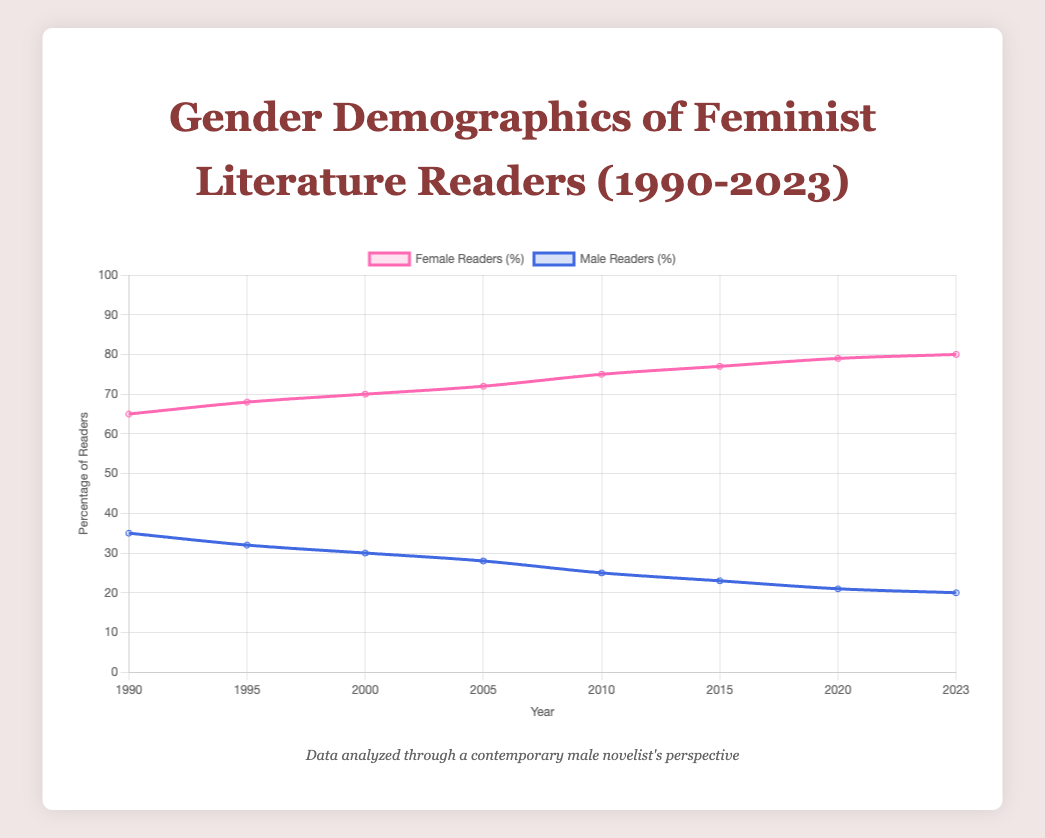What is the general trend in the percentage of female readers from 1990 to 2023? To answer this, examine the data points specifically for female readers from 1990 to 2023. Visual analysis of the line chart indicates a steady increase in the percentage of female readers over this period.
Answer: An increasing trend How did the percentage of male readers change between 1990 and 2000? Look at the male readers' percentages in 1990 and 2000. In 1990, it was 35%, and by 2000, it had decreased to 30%. The percentage of male readers decreased by 5%.
Answer: Decreased by 5% Which year saw the highest percentage of female readers, and what was it? By examining the data points or the line chart's peak for female readers, 2023 shows the highest value, with female readers at 80%.
Answer: 2023 with 80% Compare the percentage of male and female readers in 2010. How much higher is the percentage of female readers compared to male readers? In 2010, female readers were at 75%, and male readers were at 25%. The percentage of female readers is 50% higher than male readers.
Answer: 50% higher Calculate the average annual percentage difference in female readers from 1990 to 2023. Add the differences in percentage for each 5-year interval first: (68-65) + (70-68) + (72-70) + (75-72) + (77-75) + (79-77) + (80-79) = 3 + 2 + 2 + 3 + 2 + 2 + 1 = 15. Then divide by 7 intervals: 15/7 ≈ 2.14%
Answer: 2.14% In which period did the percentage of male readers decrease the most, and what was the amount? Examine the decreases in male readership percentages between each interval. The largest drop is from 2010 to 2015, where it decreased from 25% to 23%, a change of 2%.
Answer: 2010 to 2015, by 2% Identify the period with the least change in female readership percentage and state the change. The smallest change occurred between 2020 (79%) and 2023 (80%), where the percentage increased by only 1%.
Answer: 2020 to 2023, 1% Compare the visual attributes of the lines representing male and female readers. How are they distinctly represented visually in the chart? Female readers are represented by a pink line with a gradient shade, while male readers are shown with a blue line. Both lines use a tension effect for smooth curves.
Answer: Pink line and blue line What is the combined percentage of female and male readers in 1995? Sum up the percentages for female (68%) and male readers (32%) in 1995: 68 + 32 = 100%.
Answer: 100% What year saw the smallest difference between the percentage of male and female readers, and what was the difference? Identify the year with the smallest gap between male and female readership percentages. In 2023, the gap is smallest, with female at 80% and male at 20%, a 60% difference.
Answer: 2023, 60% 